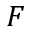<formula> <loc_0><loc_0><loc_500><loc_500>F</formula> 